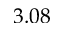Convert formula to latex. <formula><loc_0><loc_0><loc_500><loc_500>3 . 0 8</formula> 